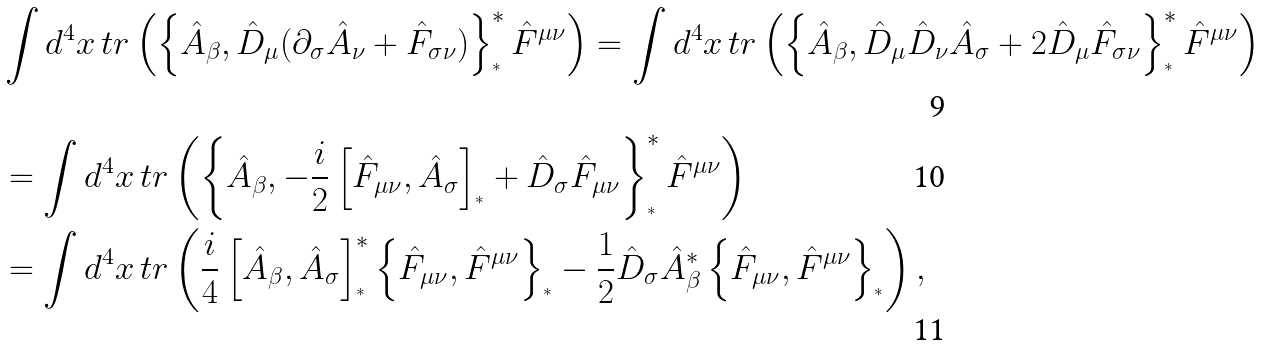<formula> <loc_0><loc_0><loc_500><loc_500>& \int d ^ { 4 } x \, t r \left ( \left \{ \hat { A } _ { \beta } , \hat { D } _ { \mu } ( \partial _ { \sigma } \hat { A } _ { \nu } + \hat { F } _ { \sigma \nu } ) \right \} _ { ^ { * } } ^ { * } \hat { F } ^ { \mu \nu } \right ) = \int d ^ { 4 } x \, t r \left ( \left \{ \hat { A } _ { \beta } , \hat { D } _ { \mu } \hat { D } _ { \nu } \hat { A } _ { \sigma } + 2 \hat { D } _ { \mu } \hat { F } _ { \sigma \nu } \right \} _ { ^ { * } } ^ { * } \hat { F } ^ { \mu \nu } \right ) \\ & = \int d ^ { 4 } x \, t r \left ( \left \{ \hat { A } _ { \beta } , - \frac { i } { 2 } \left [ \hat { F } _ { \mu \nu } , \hat { A } _ { \sigma } \right ] _ { ^ { * } } + \hat { D } _ { \sigma } \hat { F } _ { \mu \nu } \right \} _ { ^ { * } } ^ { * } \hat { F } ^ { \mu \nu } \right ) \\ & = \int d ^ { 4 } x \, t r \left ( \frac { i } { 4 } \left [ \hat { A } _ { \beta } , \hat { A } _ { \sigma } \right ] _ { ^ { * } } ^ { * } \left \{ \hat { F } _ { \mu \nu } , \hat { F } ^ { \mu \nu } \right \} _ { ^ { * } } - \frac { 1 } { 2 } \hat { D } _ { \sigma } \hat { A } _ { \beta } ^ { * } \left \{ \hat { F } _ { \mu \nu } , \hat { F } ^ { \mu \nu } \right \} _ { ^ { * } } \right ) ,</formula> 